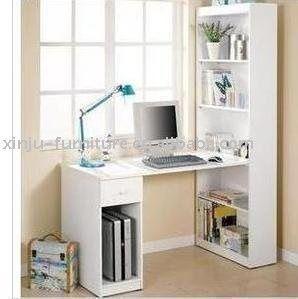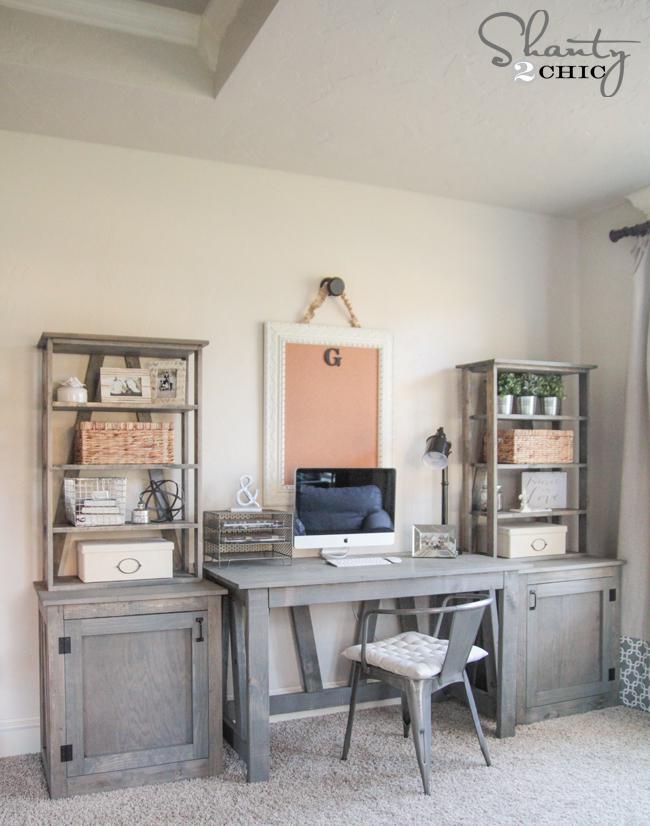The first image is the image on the left, the second image is the image on the right. Considering the images on both sides, is "A window is behind a white desk with a desktop computer on it and a bookshelf component against a wall." valid? Answer yes or no. Yes. The first image is the image on the left, the second image is the image on the right. Evaluate the accuracy of this statement regarding the images: "A desk unit in one image is comprised of a bookcase with four shelves at one end and a two-shelf bookcase at the other end, with a desktop extending between them.". Is it true? Answer yes or no. No. 